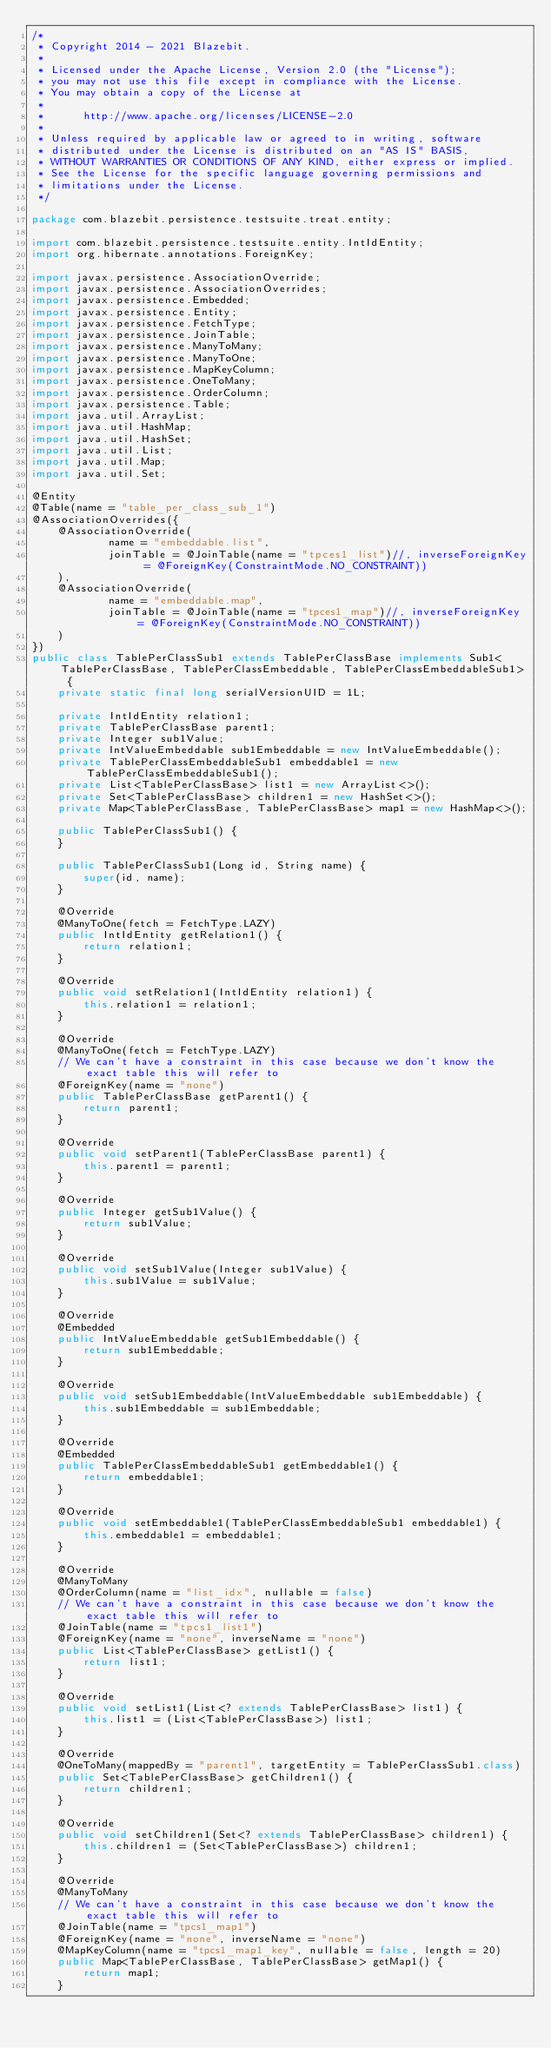<code> <loc_0><loc_0><loc_500><loc_500><_Java_>/*
 * Copyright 2014 - 2021 Blazebit.
 *
 * Licensed under the Apache License, Version 2.0 (the "License");
 * you may not use this file except in compliance with the License.
 * You may obtain a copy of the License at
 *
 *      http://www.apache.org/licenses/LICENSE-2.0
 *
 * Unless required by applicable law or agreed to in writing, software
 * distributed under the License is distributed on an "AS IS" BASIS,
 * WITHOUT WARRANTIES OR CONDITIONS OF ANY KIND, either express or implied.
 * See the License for the specific language governing permissions and
 * limitations under the License.
 */

package com.blazebit.persistence.testsuite.treat.entity;

import com.blazebit.persistence.testsuite.entity.IntIdEntity;
import org.hibernate.annotations.ForeignKey;

import javax.persistence.AssociationOverride;
import javax.persistence.AssociationOverrides;
import javax.persistence.Embedded;
import javax.persistence.Entity;
import javax.persistence.FetchType;
import javax.persistence.JoinTable;
import javax.persistence.ManyToMany;
import javax.persistence.ManyToOne;
import javax.persistence.MapKeyColumn;
import javax.persistence.OneToMany;
import javax.persistence.OrderColumn;
import javax.persistence.Table;
import java.util.ArrayList;
import java.util.HashMap;
import java.util.HashSet;
import java.util.List;
import java.util.Map;
import java.util.Set;

@Entity
@Table(name = "table_per_class_sub_1")
@AssociationOverrides({
    @AssociationOverride(
            name = "embeddable.list",
            joinTable = @JoinTable(name = "tpces1_list")//, inverseForeignKey = @ForeignKey(ConstraintMode.NO_CONSTRAINT))
    ),
    @AssociationOverride(
            name = "embeddable.map",
            joinTable = @JoinTable(name = "tpces1_map")//, inverseForeignKey = @ForeignKey(ConstraintMode.NO_CONSTRAINT))
    )
})
public class TablePerClassSub1 extends TablePerClassBase implements Sub1<TablePerClassBase, TablePerClassEmbeddable, TablePerClassEmbeddableSub1> {
    private static final long serialVersionUID = 1L;

    private IntIdEntity relation1;
    private TablePerClassBase parent1;
    private Integer sub1Value;
    private IntValueEmbeddable sub1Embeddable = new IntValueEmbeddable();
    private TablePerClassEmbeddableSub1 embeddable1 = new TablePerClassEmbeddableSub1();
    private List<TablePerClassBase> list1 = new ArrayList<>();
    private Set<TablePerClassBase> children1 = new HashSet<>();
    private Map<TablePerClassBase, TablePerClassBase> map1 = new HashMap<>();

    public TablePerClassSub1() {
    }

    public TablePerClassSub1(Long id, String name) {
        super(id, name);
    }

    @Override
    @ManyToOne(fetch = FetchType.LAZY)
    public IntIdEntity getRelation1() {
        return relation1;
    }

    @Override
    public void setRelation1(IntIdEntity relation1) {
        this.relation1 = relation1;
    }

    @Override
    @ManyToOne(fetch = FetchType.LAZY)
    // We can't have a constraint in this case because we don't know the exact table this will refer to
    @ForeignKey(name = "none")
    public TablePerClassBase getParent1() {
        return parent1;
    }

    @Override
    public void setParent1(TablePerClassBase parent1) {
        this.parent1 = parent1;
    }

    @Override
    public Integer getSub1Value() {
        return sub1Value;
    }

    @Override
    public void setSub1Value(Integer sub1Value) {
        this.sub1Value = sub1Value;
    }

    @Override
    @Embedded
    public IntValueEmbeddable getSub1Embeddable() {
        return sub1Embeddable;
    }

    @Override
    public void setSub1Embeddable(IntValueEmbeddable sub1Embeddable) {
        this.sub1Embeddable = sub1Embeddable;
    }

    @Override
    @Embedded
    public TablePerClassEmbeddableSub1 getEmbeddable1() {
        return embeddable1;
    }

    @Override
    public void setEmbeddable1(TablePerClassEmbeddableSub1 embeddable1) {
        this.embeddable1 = embeddable1;
    }

    @Override
    @ManyToMany
    @OrderColumn(name = "list_idx", nullable = false)
    // We can't have a constraint in this case because we don't know the exact table this will refer to
    @JoinTable(name = "tpcs1_list1")
    @ForeignKey(name = "none", inverseName = "none")
    public List<TablePerClassBase> getList1() {
        return list1;
    }

    @Override
    public void setList1(List<? extends TablePerClassBase> list1) {
        this.list1 = (List<TablePerClassBase>) list1;
    }

    @Override
    @OneToMany(mappedBy = "parent1", targetEntity = TablePerClassSub1.class)
    public Set<TablePerClassBase> getChildren1() {
        return children1;
    }

    @Override
    public void setChildren1(Set<? extends TablePerClassBase> children1) {
        this.children1 = (Set<TablePerClassBase>) children1;
    }
    
    @Override
    @ManyToMany
    // We can't have a constraint in this case because we don't know the exact table this will refer to
    @JoinTable(name = "tpcs1_map1")
    @ForeignKey(name = "none", inverseName = "none")
    @MapKeyColumn(name = "tpcs1_map1_key", nullable = false, length = 20)
    public Map<TablePerClassBase, TablePerClassBase> getMap1() {
        return map1;
    }
</code> 